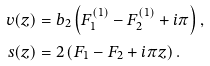<formula> <loc_0><loc_0><loc_500><loc_500>v ( z ) & = b _ { 2 } \left ( F _ { 1 } ^ { ( 1 ) } - F _ { 2 } ^ { ( 1 ) } + i \pi \right ) , \\ s ( z ) & = 2 \left ( F _ { 1 } - F _ { 2 } + i \pi z \right ) .</formula> 